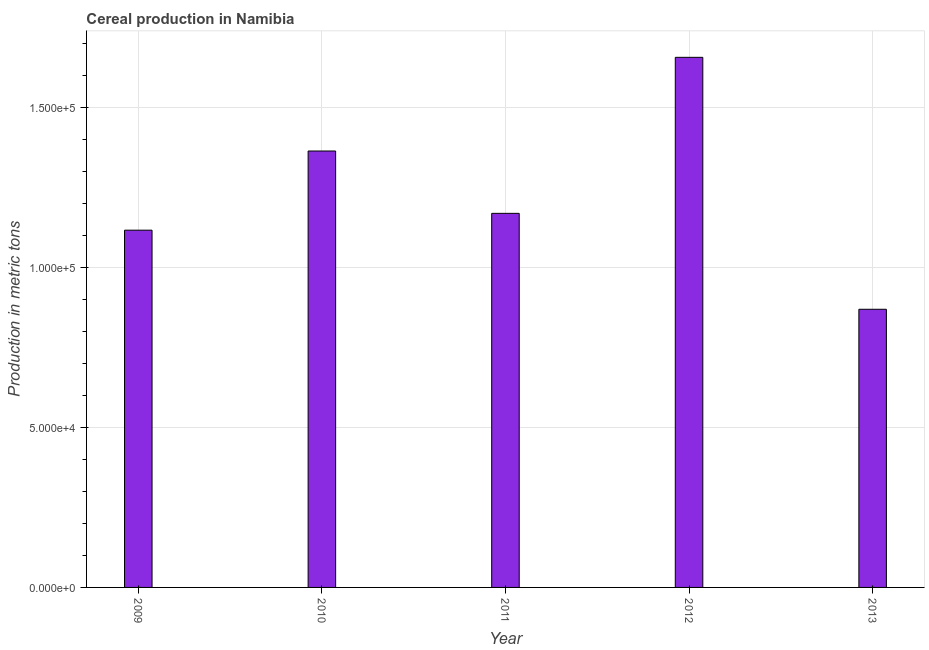Does the graph contain any zero values?
Keep it short and to the point. No. What is the title of the graph?
Ensure brevity in your answer.  Cereal production in Namibia. What is the label or title of the X-axis?
Your answer should be very brief. Year. What is the label or title of the Y-axis?
Keep it short and to the point. Production in metric tons. What is the cereal production in 2010?
Offer a very short reply. 1.36e+05. Across all years, what is the maximum cereal production?
Keep it short and to the point. 1.66e+05. Across all years, what is the minimum cereal production?
Give a very brief answer. 8.70e+04. In which year was the cereal production minimum?
Offer a very short reply. 2013. What is the sum of the cereal production?
Keep it short and to the point. 6.18e+05. What is the difference between the cereal production in 2011 and 2013?
Offer a terse response. 3.00e+04. What is the average cereal production per year?
Your answer should be very brief. 1.24e+05. What is the median cereal production?
Keep it short and to the point. 1.17e+05. Do a majority of the years between 2009 and 2011 (inclusive) have cereal production greater than 130000 metric tons?
Keep it short and to the point. No. What is the ratio of the cereal production in 2011 to that in 2012?
Your answer should be compact. 0.71. What is the difference between the highest and the second highest cereal production?
Offer a very short reply. 2.93e+04. What is the difference between the highest and the lowest cereal production?
Your response must be concise. 7.88e+04. In how many years, is the cereal production greater than the average cereal production taken over all years?
Offer a very short reply. 2. How many bars are there?
Offer a very short reply. 5. How many years are there in the graph?
Offer a very short reply. 5. Are the values on the major ticks of Y-axis written in scientific E-notation?
Your response must be concise. Yes. What is the Production in metric tons of 2009?
Give a very brief answer. 1.12e+05. What is the Production in metric tons of 2010?
Keep it short and to the point. 1.36e+05. What is the Production in metric tons of 2011?
Provide a short and direct response. 1.17e+05. What is the Production in metric tons in 2012?
Your answer should be compact. 1.66e+05. What is the Production in metric tons of 2013?
Ensure brevity in your answer.  8.70e+04. What is the difference between the Production in metric tons in 2009 and 2010?
Make the answer very short. -2.48e+04. What is the difference between the Production in metric tons in 2009 and 2011?
Offer a very short reply. -5262. What is the difference between the Production in metric tons in 2009 and 2012?
Give a very brief answer. -5.41e+04. What is the difference between the Production in metric tons in 2009 and 2013?
Your answer should be very brief. 2.47e+04. What is the difference between the Production in metric tons in 2010 and 2011?
Your answer should be very brief. 1.95e+04. What is the difference between the Production in metric tons in 2010 and 2012?
Ensure brevity in your answer.  -2.93e+04. What is the difference between the Production in metric tons in 2010 and 2013?
Provide a succinct answer. 4.95e+04. What is the difference between the Production in metric tons in 2011 and 2012?
Provide a succinct answer. -4.88e+04. What is the difference between the Production in metric tons in 2012 and 2013?
Make the answer very short. 7.88e+04. What is the ratio of the Production in metric tons in 2009 to that in 2010?
Your answer should be very brief. 0.82. What is the ratio of the Production in metric tons in 2009 to that in 2011?
Your response must be concise. 0.95. What is the ratio of the Production in metric tons in 2009 to that in 2012?
Keep it short and to the point. 0.67. What is the ratio of the Production in metric tons in 2009 to that in 2013?
Your response must be concise. 1.28. What is the ratio of the Production in metric tons in 2010 to that in 2011?
Keep it short and to the point. 1.17. What is the ratio of the Production in metric tons in 2010 to that in 2012?
Your answer should be very brief. 0.82. What is the ratio of the Production in metric tons in 2010 to that in 2013?
Your answer should be compact. 1.57. What is the ratio of the Production in metric tons in 2011 to that in 2012?
Your answer should be very brief. 0.71. What is the ratio of the Production in metric tons in 2011 to that in 2013?
Give a very brief answer. 1.34. What is the ratio of the Production in metric tons in 2012 to that in 2013?
Offer a very short reply. 1.91. 